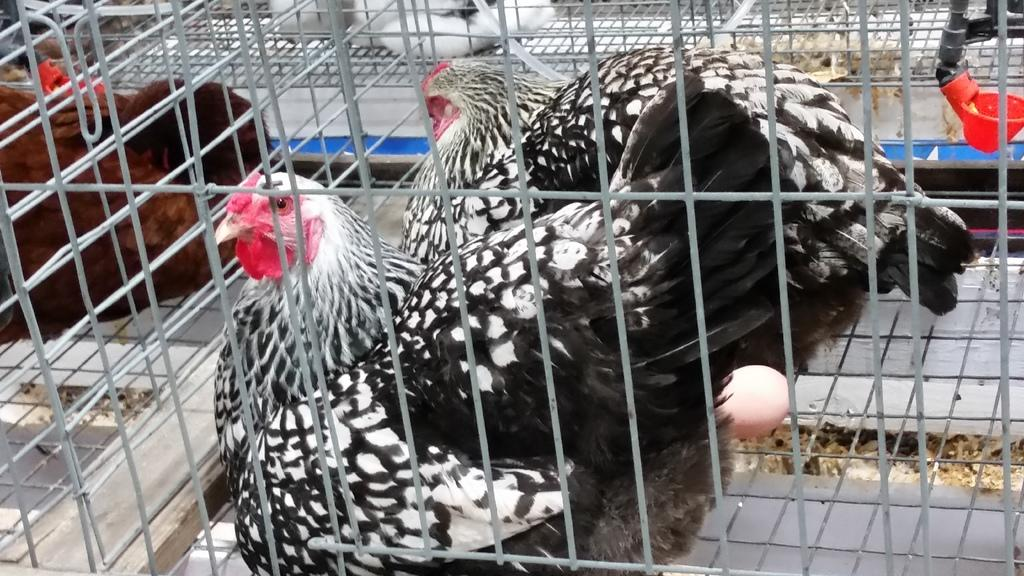What animals are present in the image? There are cocks in the image. Where are the cocks located? The cocks are in cages. What type of bait is being used to attract the cocks in the image? There is no bait present in the image, as the cocks are in cages. What scent can be detected from the cocks in the image? The image does not provide any information about the scent of the cocks. 